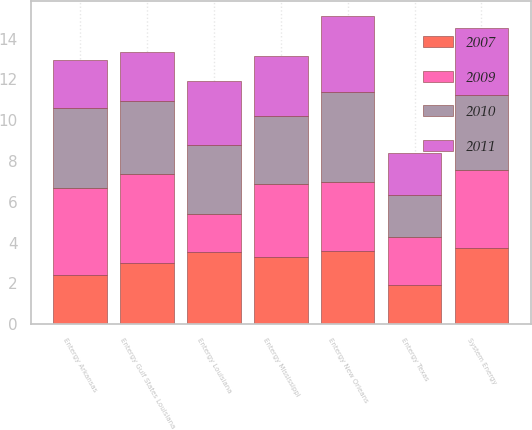<chart> <loc_0><loc_0><loc_500><loc_500><stacked_bar_chart><ecel><fcel>Entergy Arkansas<fcel>Entergy Gulf States Louisiana<fcel>Entergy Louisiana<fcel>Entergy Mississippi<fcel>Entergy New Orleans<fcel>Entergy Texas<fcel>System Energy<nl><fcel>2009<fcel>4.31<fcel>4.36<fcel>1.86<fcel>3.55<fcel>3.35<fcel>2.34<fcel>3.85<nl><fcel>2010<fcel>3.91<fcel>3.58<fcel>3.41<fcel>3.35<fcel>4.43<fcel>2.1<fcel>3.64<nl><fcel>2007<fcel>2.39<fcel>2.99<fcel>3.52<fcel>3.31<fcel>3.61<fcel>1.92<fcel>3.73<nl><fcel>2011<fcel>2.33<fcel>2.44<fcel>3.14<fcel>2.92<fcel>3.71<fcel>2.04<fcel>3.29<nl></chart> 